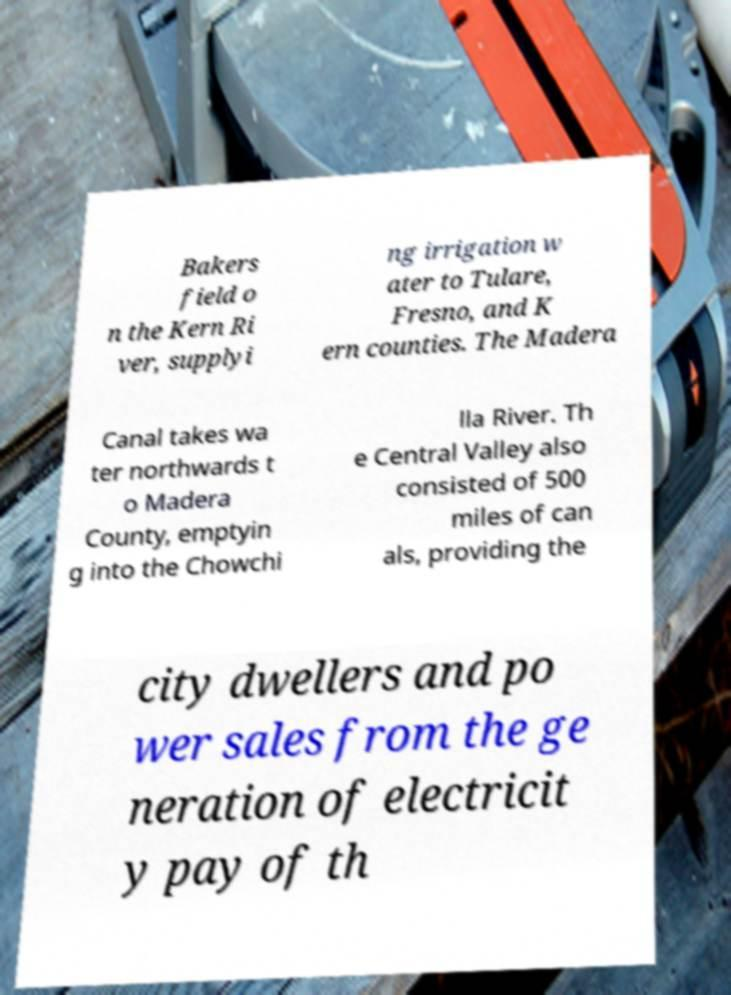What messages or text are displayed in this image? I need them in a readable, typed format. Bakers field o n the Kern Ri ver, supplyi ng irrigation w ater to Tulare, Fresno, and K ern counties. The Madera Canal takes wa ter northwards t o Madera County, emptyin g into the Chowchi lla River. Th e Central Valley also consisted of 500 miles of can als, providing the city dwellers and po wer sales from the ge neration of electricit y pay of th 